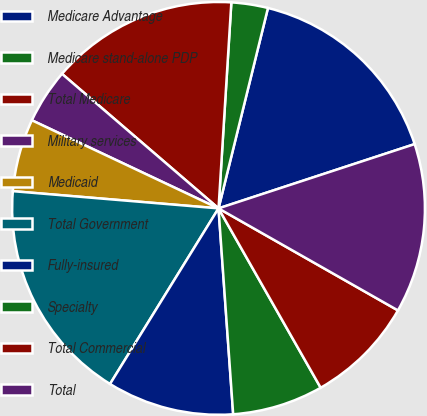<chart> <loc_0><loc_0><loc_500><loc_500><pie_chart><fcel>Medicare Advantage<fcel>Medicare stand-alone PDP<fcel>Total Medicare<fcel>Military services<fcel>Medicaid<fcel>Total Government<fcel>Fully-insured<fcel>Specialty<fcel>Total Commercial<fcel>Total<nl><fcel>16.11%<fcel>2.86%<fcel>14.69%<fcel>4.28%<fcel>5.69%<fcel>17.52%<fcel>9.94%<fcel>7.11%<fcel>8.53%<fcel>13.27%<nl></chart> 